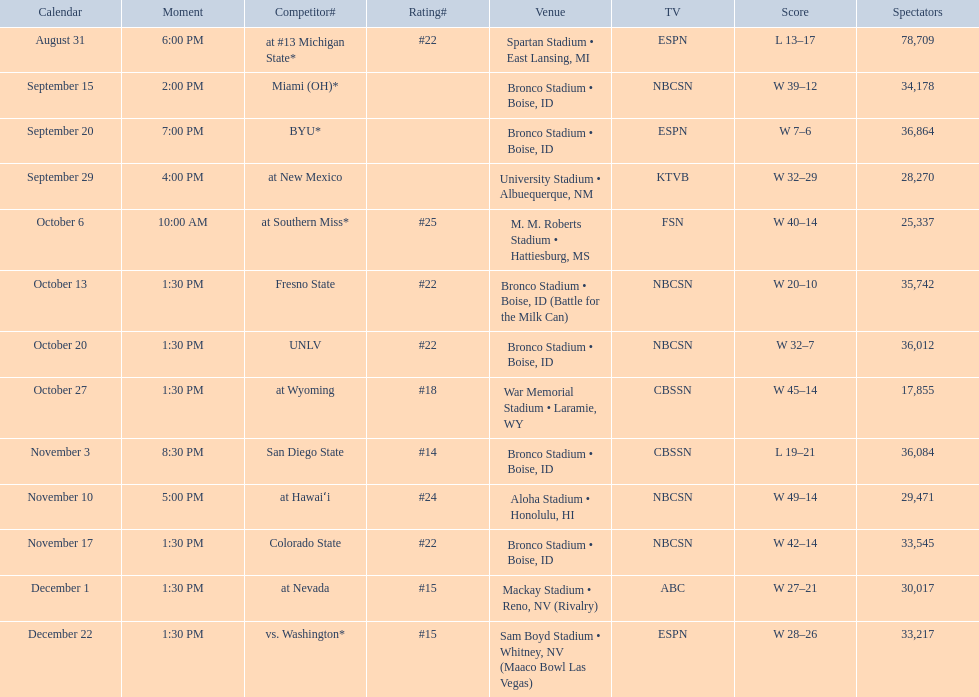What was the team's listed rankings for the season? #22, , , , #25, #22, #22, #18, #14, #24, #22, #15, #15. Which of these ranks is the best? #14. 